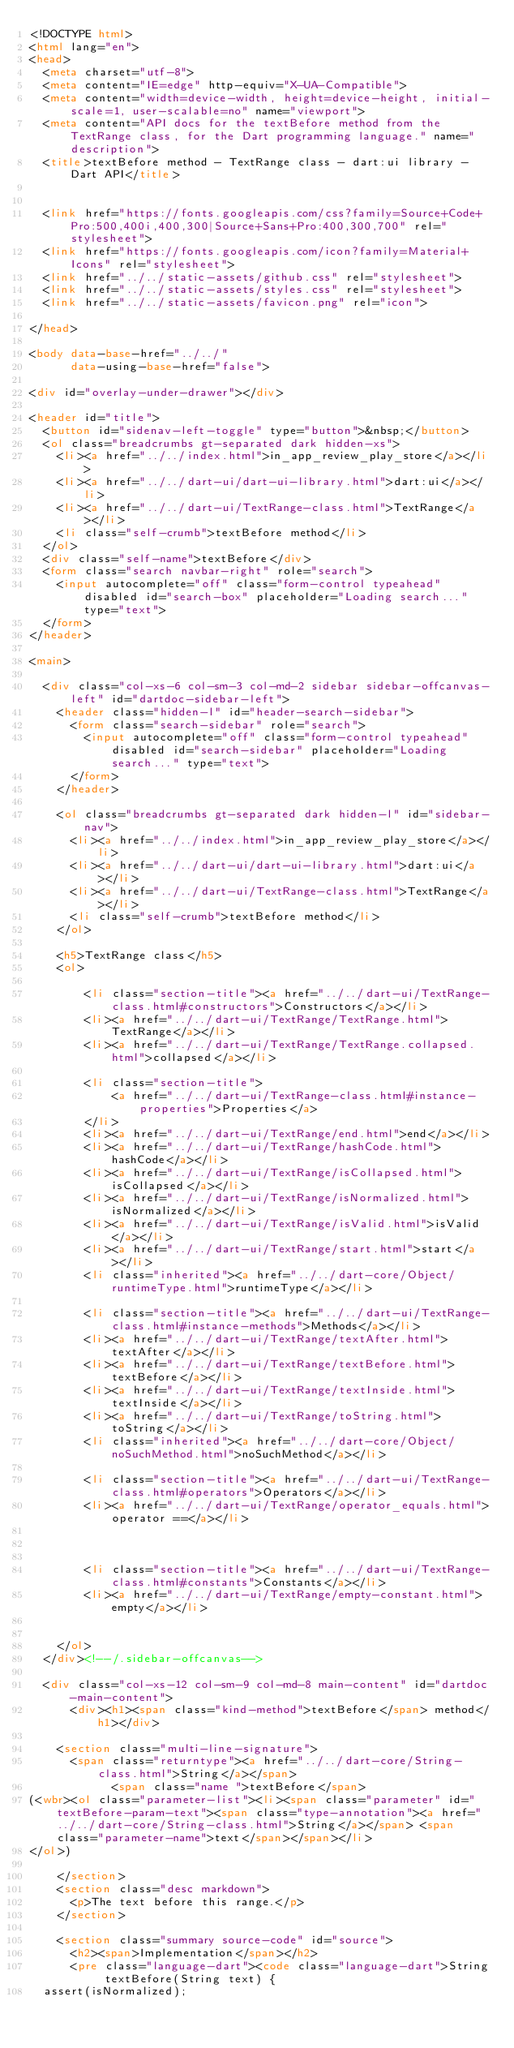Convert code to text. <code><loc_0><loc_0><loc_500><loc_500><_HTML_><!DOCTYPE html>
<html lang="en">
<head>
  <meta charset="utf-8">
  <meta content="IE=edge" http-equiv="X-UA-Compatible">
  <meta content="width=device-width, height=device-height, initial-scale=1, user-scalable=no" name="viewport">
  <meta content="API docs for the textBefore method from the TextRange class, for the Dart programming language." name="description">
  <title>textBefore method - TextRange class - dart:ui library - Dart API</title>

  
  <link href="https://fonts.googleapis.com/css?family=Source+Code+Pro:500,400i,400,300|Source+Sans+Pro:400,300,700" rel="stylesheet">
  <link href="https://fonts.googleapis.com/icon?family=Material+Icons" rel="stylesheet">
  <link href="../../static-assets/github.css" rel="stylesheet">
  <link href="../../static-assets/styles.css" rel="stylesheet">
  <link href="../../static-assets/favicon.png" rel="icon">

</head>

<body data-base-href="../../"
      data-using-base-href="false">

<div id="overlay-under-drawer"></div>

<header id="title">
  <button id="sidenav-left-toggle" type="button">&nbsp;</button>
  <ol class="breadcrumbs gt-separated dark hidden-xs">
    <li><a href="../../index.html">in_app_review_play_store</a></li>
    <li><a href="../../dart-ui/dart-ui-library.html">dart:ui</a></li>
    <li><a href="../../dart-ui/TextRange-class.html">TextRange</a></li>
    <li class="self-crumb">textBefore method</li>
  </ol>
  <div class="self-name">textBefore</div>
  <form class="search navbar-right" role="search">
    <input autocomplete="off" class="form-control typeahead" disabled id="search-box" placeholder="Loading search..." type="text">
  </form>
</header>

<main>

  <div class="col-xs-6 col-sm-3 col-md-2 sidebar sidebar-offcanvas-left" id="dartdoc-sidebar-left">
    <header class="hidden-l" id="header-search-sidebar">
      <form class="search-sidebar" role="search">
        <input autocomplete="off" class="form-control typeahead" disabled id="search-sidebar" placeholder="Loading search..." type="text">
      </form>
    </header>
    
    <ol class="breadcrumbs gt-separated dark hidden-l" id="sidebar-nav">
      <li><a href="../../index.html">in_app_review_play_store</a></li>
      <li><a href="../../dart-ui/dart-ui-library.html">dart:ui</a></li>
      <li><a href="../../dart-ui/TextRange-class.html">TextRange</a></li>
      <li class="self-crumb">textBefore method</li>
    </ol>
    
    <h5>TextRange class</h5>
    <ol>
    
        <li class="section-title"><a href="../../dart-ui/TextRange-class.html#constructors">Constructors</a></li>
        <li><a href="../../dart-ui/TextRange/TextRange.html">TextRange</a></li>
        <li><a href="../../dart-ui/TextRange/TextRange.collapsed.html">collapsed</a></li>
    
        <li class="section-title">
            <a href="../../dart-ui/TextRange-class.html#instance-properties">Properties</a>
        </li>
        <li><a href="../../dart-ui/TextRange/end.html">end</a></li>
        <li><a href="../../dart-ui/TextRange/hashCode.html">hashCode</a></li>
        <li><a href="../../dart-ui/TextRange/isCollapsed.html">isCollapsed</a></li>
        <li><a href="../../dart-ui/TextRange/isNormalized.html">isNormalized</a></li>
        <li><a href="../../dart-ui/TextRange/isValid.html">isValid</a></li>
        <li><a href="../../dart-ui/TextRange/start.html">start</a></li>
        <li class="inherited"><a href="../../dart-core/Object/runtimeType.html">runtimeType</a></li>
    
        <li class="section-title"><a href="../../dart-ui/TextRange-class.html#instance-methods">Methods</a></li>
        <li><a href="../../dart-ui/TextRange/textAfter.html">textAfter</a></li>
        <li><a href="../../dart-ui/TextRange/textBefore.html">textBefore</a></li>
        <li><a href="../../dart-ui/TextRange/textInside.html">textInside</a></li>
        <li><a href="../../dart-ui/TextRange/toString.html">toString</a></li>
        <li class="inherited"><a href="../../dart-core/Object/noSuchMethod.html">noSuchMethod</a></li>
    
        <li class="section-title"><a href="../../dart-ui/TextRange-class.html#operators">Operators</a></li>
        <li><a href="../../dart-ui/TextRange/operator_equals.html">operator ==</a></li>
    
    
    
        <li class="section-title"><a href="../../dart-ui/TextRange-class.html#constants">Constants</a></li>
        <li><a href="../../dart-ui/TextRange/empty-constant.html">empty</a></li>
    
    
    </ol>
  </div><!--/.sidebar-offcanvas-->

  <div class="col-xs-12 col-sm-9 col-md-8 main-content" id="dartdoc-main-content">
      <div><h1><span class="kind-method">textBefore</span> method</h1></div>

    <section class="multi-line-signature">
      <span class="returntype"><a href="../../dart-core/String-class.html">String</a></span>
            <span class="name ">textBefore</span>
(<wbr><ol class="parameter-list"><li><span class="parameter" id="textBefore-param-text"><span class="type-annotation"><a href="../../dart-core/String-class.html">String</a></span> <span class="parameter-name">text</span></span></li>
</ol>)
      
    </section>
    <section class="desc markdown">
      <p>The text before this range.</p>
    </section>
    
    <section class="summary source-code" id="source">
      <h2><span>Implementation</span></h2>
      <pre class="language-dart"><code class="language-dart">String textBefore(String text) {
  assert(isNormalized);</code> 